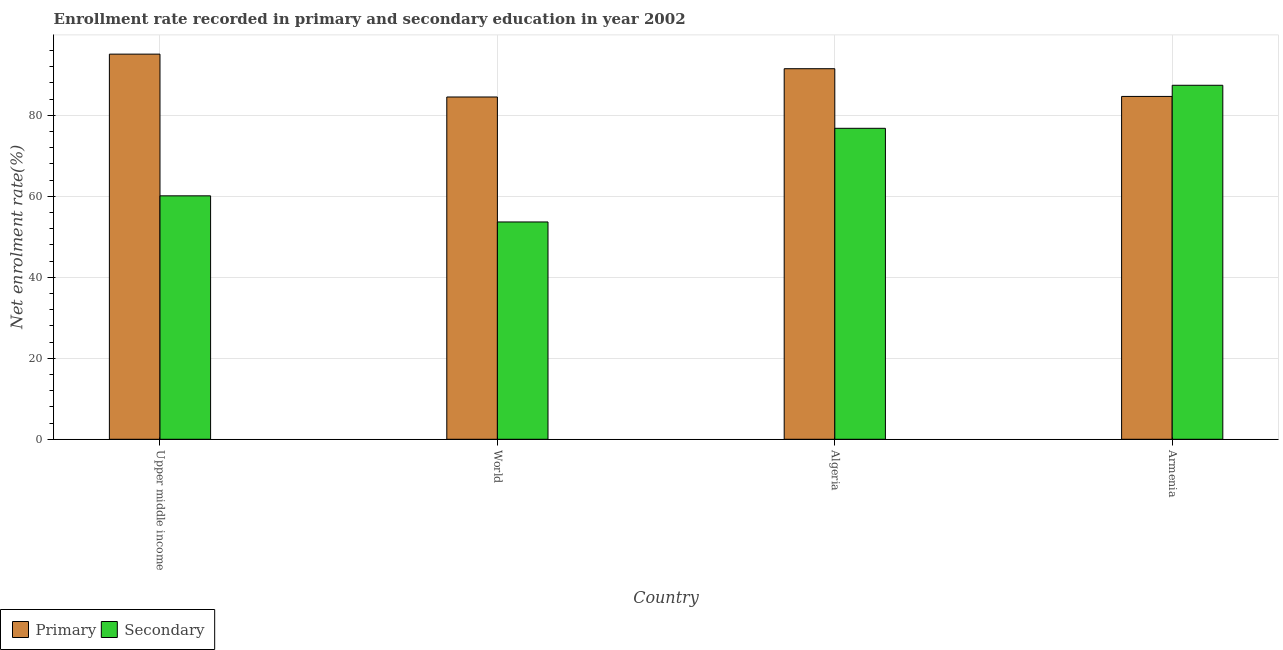How many different coloured bars are there?
Your response must be concise. 2. How many bars are there on the 3rd tick from the left?
Ensure brevity in your answer.  2. What is the label of the 2nd group of bars from the left?
Provide a short and direct response. World. What is the enrollment rate in primary education in Algeria?
Keep it short and to the point. 91.52. Across all countries, what is the maximum enrollment rate in primary education?
Make the answer very short. 95.12. Across all countries, what is the minimum enrollment rate in secondary education?
Give a very brief answer. 53.67. In which country was the enrollment rate in primary education maximum?
Provide a succinct answer. Upper middle income. In which country was the enrollment rate in primary education minimum?
Your response must be concise. World. What is the total enrollment rate in secondary education in the graph?
Your answer should be compact. 278.01. What is the difference between the enrollment rate in primary education in Armenia and that in World?
Give a very brief answer. 0.14. What is the difference between the enrollment rate in primary education in Upper middle income and the enrollment rate in secondary education in World?
Provide a succinct answer. 41.45. What is the average enrollment rate in primary education per country?
Provide a short and direct response. 88.96. What is the difference between the enrollment rate in primary education and enrollment rate in secondary education in Armenia?
Your answer should be compact. -2.75. What is the ratio of the enrollment rate in primary education in Armenia to that in World?
Make the answer very short. 1. What is the difference between the highest and the second highest enrollment rate in secondary education?
Offer a very short reply. 10.63. What is the difference between the highest and the lowest enrollment rate in primary education?
Your answer should be very brief. 10.59. Is the sum of the enrollment rate in secondary education in Upper middle income and World greater than the maximum enrollment rate in primary education across all countries?
Ensure brevity in your answer.  Yes. What does the 1st bar from the left in Upper middle income represents?
Your answer should be compact. Primary. What does the 2nd bar from the right in World represents?
Provide a succinct answer. Primary. How many bars are there?
Give a very brief answer. 8. Are all the bars in the graph horizontal?
Provide a short and direct response. No. Are the values on the major ticks of Y-axis written in scientific E-notation?
Your response must be concise. No. Does the graph contain grids?
Your answer should be compact. Yes. How are the legend labels stacked?
Provide a succinct answer. Horizontal. What is the title of the graph?
Offer a terse response. Enrollment rate recorded in primary and secondary education in year 2002. Does "Female population" appear as one of the legend labels in the graph?
Offer a very short reply. No. What is the label or title of the X-axis?
Your answer should be compact. Country. What is the label or title of the Y-axis?
Provide a succinct answer. Net enrolment rate(%). What is the Net enrolment rate(%) in Primary in Upper middle income?
Offer a very short reply. 95.12. What is the Net enrolment rate(%) of Secondary in Upper middle income?
Your answer should be very brief. 60.12. What is the Net enrolment rate(%) in Primary in World?
Your answer should be compact. 84.53. What is the Net enrolment rate(%) in Secondary in World?
Your answer should be compact. 53.67. What is the Net enrolment rate(%) of Primary in Algeria?
Ensure brevity in your answer.  91.52. What is the Net enrolment rate(%) in Secondary in Algeria?
Provide a succinct answer. 76.8. What is the Net enrolment rate(%) in Primary in Armenia?
Offer a very short reply. 84.67. What is the Net enrolment rate(%) of Secondary in Armenia?
Ensure brevity in your answer.  87.43. Across all countries, what is the maximum Net enrolment rate(%) in Primary?
Provide a succinct answer. 95.12. Across all countries, what is the maximum Net enrolment rate(%) in Secondary?
Provide a short and direct response. 87.43. Across all countries, what is the minimum Net enrolment rate(%) in Primary?
Give a very brief answer. 84.53. Across all countries, what is the minimum Net enrolment rate(%) in Secondary?
Your answer should be compact. 53.67. What is the total Net enrolment rate(%) of Primary in the graph?
Offer a terse response. 355.83. What is the total Net enrolment rate(%) of Secondary in the graph?
Provide a succinct answer. 278.01. What is the difference between the Net enrolment rate(%) of Primary in Upper middle income and that in World?
Ensure brevity in your answer.  10.59. What is the difference between the Net enrolment rate(%) in Secondary in Upper middle income and that in World?
Give a very brief answer. 6.45. What is the difference between the Net enrolment rate(%) of Primary in Upper middle income and that in Algeria?
Ensure brevity in your answer.  3.6. What is the difference between the Net enrolment rate(%) in Secondary in Upper middle income and that in Algeria?
Make the answer very short. -16.68. What is the difference between the Net enrolment rate(%) of Primary in Upper middle income and that in Armenia?
Offer a very short reply. 10.44. What is the difference between the Net enrolment rate(%) in Secondary in Upper middle income and that in Armenia?
Offer a very short reply. -27.31. What is the difference between the Net enrolment rate(%) of Primary in World and that in Algeria?
Ensure brevity in your answer.  -6.98. What is the difference between the Net enrolment rate(%) of Secondary in World and that in Algeria?
Your response must be concise. -23.13. What is the difference between the Net enrolment rate(%) in Primary in World and that in Armenia?
Offer a very short reply. -0.14. What is the difference between the Net enrolment rate(%) of Secondary in World and that in Armenia?
Offer a very short reply. -33.76. What is the difference between the Net enrolment rate(%) in Primary in Algeria and that in Armenia?
Your response must be concise. 6.84. What is the difference between the Net enrolment rate(%) in Secondary in Algeria and that in Armenia?
Provide a short and direct response. -10.63. What is the difference between the Net enrolment rate(%) of Primary in Upper middle income and the Net enrolment rate(%) of Secondary in World?
Provide a succinct answer. 41.45. What is the difference between the Net enrolment rate(%) of Primary in Upper middle income and the Net enrolment rate(%) of Secondary in Algeria?
Offer a terse response. 18.32. What is the difference between the Net enrolment rate(%) in Primary in Upper middle income and the Net enrolment rate(%) in Secondary in Armenia?
Your answer should be compact. 7.69. What is the difference between the Net enrolment rate(%) of Primary in World and the Net enrolment rate(%) of Secondary in Algeria?
Provide a succinct answer. 7.73. What is the difference between the Net enrolment rate(%) in Primary in World and the Net enrolment rate(%) in Secondary in Armenia?
Ensure brevity in your answer.  -2.89. What is the difference between the Net enrolment rate(%) of Primary in Algeria and the Net enrolment rate(%) of Secondary in Armenia?
Keep it short and to the point. 4.09. What is the average Net enrolment rate(%) of Primary per country?
Your answer should be compact. 88.96. What is the average Net enrolment rate(%) in Secondary per country?
Your answer should be very brief. 69.5. What is the difference between the Net enrolment rate(%) in Primary and Net enrolment rate(%) in Secondary in Upper middle income?
Keep it short and to the point. 35. What is the difference between the Net enrolment rate(%) in Primary and Net enrolment rate(%) in Secondary in World?
Ensure brevity in your answer.  30.86. What is the difference between the Net enrolment rate(%) of Primary and Net enrolment rate(%) of Secondary in Algeria?
Offer a very short reply. 14.72. What is the difference between the Net enrolment rate(%) in Primary and Net enrolment rate(%) in Secondary in Armenia?
Your answer should be very brief. -2.75. What is the ratio of the Net enrolment rate(%) in Primary in Upper middle income to that in World?
Make the answer very short. 1.13. What is the ratio of the Net enrolment rate(%) in Secondary in Upper middle income to that in World?
Keep it short and to the point. 1.12. What is the ratio of the Net enrolment rate(%) in Primary in Upper middle income to that in Algeria?
Ensure brevity in your answer.  1.04. What is the ratio of the Net enrolment rate(%) in Secondary in Upper middle income to that in Algeria?
Provide a short and direct response. 0.78. What is the ratio of the Net enrolment rate(%) of Primary in Upper middle income to that in Armenia?
Make the answer very short. 1.12. What is the ratio of the Net enrolment rate(%) of Secondary in Upper middle income to that in Armenia?
Provide a succinct answer. 0.69. What is the ratio of the Net enrolment rate(%) of Primary in World to that in Algeria?
Your answer should be compact. 0.92. What is the ratio of the Net enrolment rate(%) in Secondary in World to that in Algeria?
Your response must be concise. 0.7. What is the ratio of the Net enrolment rate(%) in Secondary in World to that in Armenia?
Keep it short and to the point. 0.61. What is the ratio of the Net enrolment rate(%) of Primary in Algeria to that in Armenia?
Keep it short and to the point. 1.08. What is the ratio of the Net enrolment rate(%) in Secondary in Algeria to that in Armenia?
Offer a terse response. 0.88. What is the difference between the highest and the second highest Net enrolment rate(%) of Primary?
Your answer should be very brief. 3.6. What is the difference between the highest and the second highest Net enrolment rate(%) of Secondary?
Provide a short and direct response. 10.63. What is the difference between the highest and the lowest Net enrolment rate(%) of Primary?
Make the answer very short. 10.59. What is the difference between the highest and the lowest Net enrolment rate(%) of Secondary?
Your response must be concise. 33.76. 